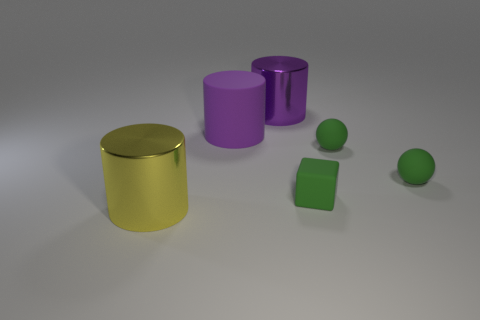Subtract all yellow cylinders. How many cylinders are left? 2 Subtract all gray blocks. How many purple cylinders are left? 2 Add 2 metallic things. How many objects exist? 8 Subtract all yellow cylinders. How many cylinders are left? 2 Subtract all balls. How many objects are left? 4 Subtract 2 spheres. How many spheres are left? 0 Subtract all red blocks. Subtract all red spheres. How many blocks are left? 1 Subtract all green metal things. Subtract all big metallic cylinders. How many objects are left? 4 Add 1 matte objects. How many matte objects are left? 5 Add 1 tiny matte spheres. How many tiny matte spheres exist? 3 